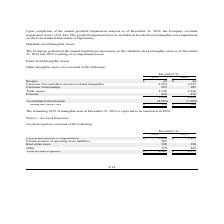According to Lifeway Foods's financial document, What is the value of the intangible asset at December 31, 2019 expected to be amortized in 2020? According to the financial document, $152. The relevant text states: "The remaining $152 of intangible asset at December 31, 2019 is expected to be amortized in 2020. Note 6 – Accrued Expen..." Also, What is the value of recipes in 2018 and 2019 respectively? The document shows two values: $ 44 and $ 44. From the document: "Recipes $ 44 $ 44..." Also, What is the value of customer relationships in 2018 and 2019 respectively? The document shows two values: 985 and 985. From the document: "Customer relationships 985 985..." Also, can you calculate: What is the change in the value of customer relationships between 2018 and 2019? I cannot find a specific answer to this question in the financial document. Also, can you calculate: What is the average value of trade names for both 2018 and 2019? To answer this question, I need to perform calculations using the financial data. The calculation is: (2,248+2,248)/2, which equals 2248. This is based on the information: "Trade names 2,248 2,248..." Additionally, Which year has a higher value of net intangible assets? According to the financial document, 2018. The relevant text states: "2019 2018..." 